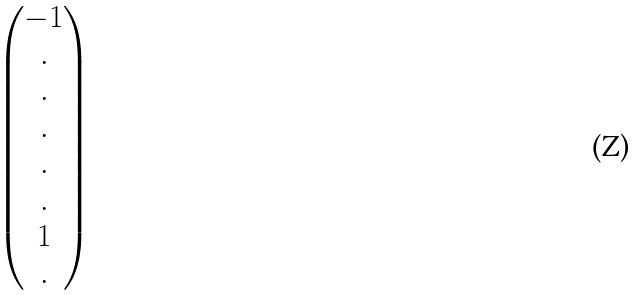<formula> <loc_0><loc_0><loc_500><loc_500>\begin{pmatrix} - 1 \\ . \\ . \\ . \\ . \\ . \\ 1 \\ . \\ \end{pmatrix}</formula> 